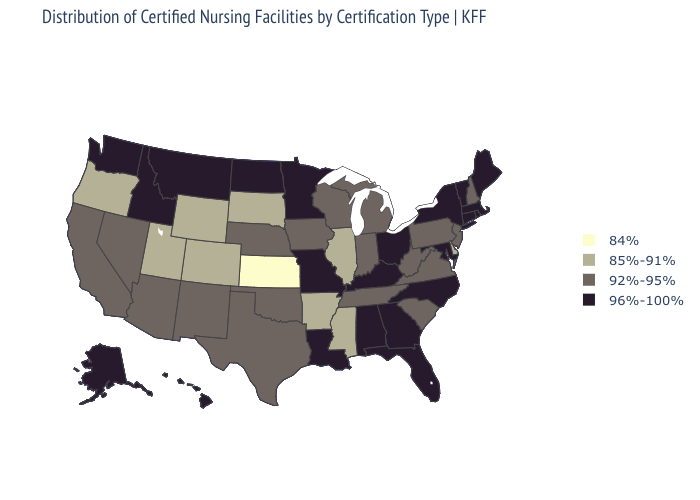Does Nevada have a higher value than North Carolina?
Answer briefly. No. Name the states that have a value in the range 92%-95%?
Concise answer only. Arizona, California, Indiana, Iowa, Michigan, Nebraska, Nevada, New Hampshire, New Jersey, New Mexico, Oklahoma, Pennsylvania, South Carolina, Tennessee, Texas, Virginia, West Virginia, Wisconsin. Name the states that have a value in the range 96%-100%?
Quick response, please. Alabama, Alaska, Connecticut, Florida, Georgia, Hawaii, Idaho, Kentucky, Louisiana, Maine, Maryland, Massachusetts, Minnesota, Missouri, Montana, New York, North Carolina, North Dakota, Ohio, Rhode Island, Vermont, Washington. Among the states that border Wyoming , which have the lowest value?
Short answer required. Colorado, South Dakota, Utah. Among the states that border South Dakota , which have the lowest value?
Keep it brief. Wyoming. Does New Mexico have the highest value in the USA?
Be succinct. No. Is the legend a continuous bar?
Write a very short answer. No. Among the states that border Louisiana , which have the highest value?
Quick response, please. Texas. What is the value of Pennsylvania?
Give a very brief answer. 92%-95%. What is the value of Nebraska?
Quick response, please. 92%-95%. Among the states that border Arkansas , does Mississippi have the lowest value?
Answer briefly. Yes. What is the lowest value in the Northeast?
Quick response, please. 92%-95%. Among the states that border Pennsylvania , which have the lowest value?
Answer briefly. Delaware. Does Wisconsin have the highest value in the MidWest?
Write a very short answer. No. Does Illinois have the same value as New York?
Write a very short answer. No. 